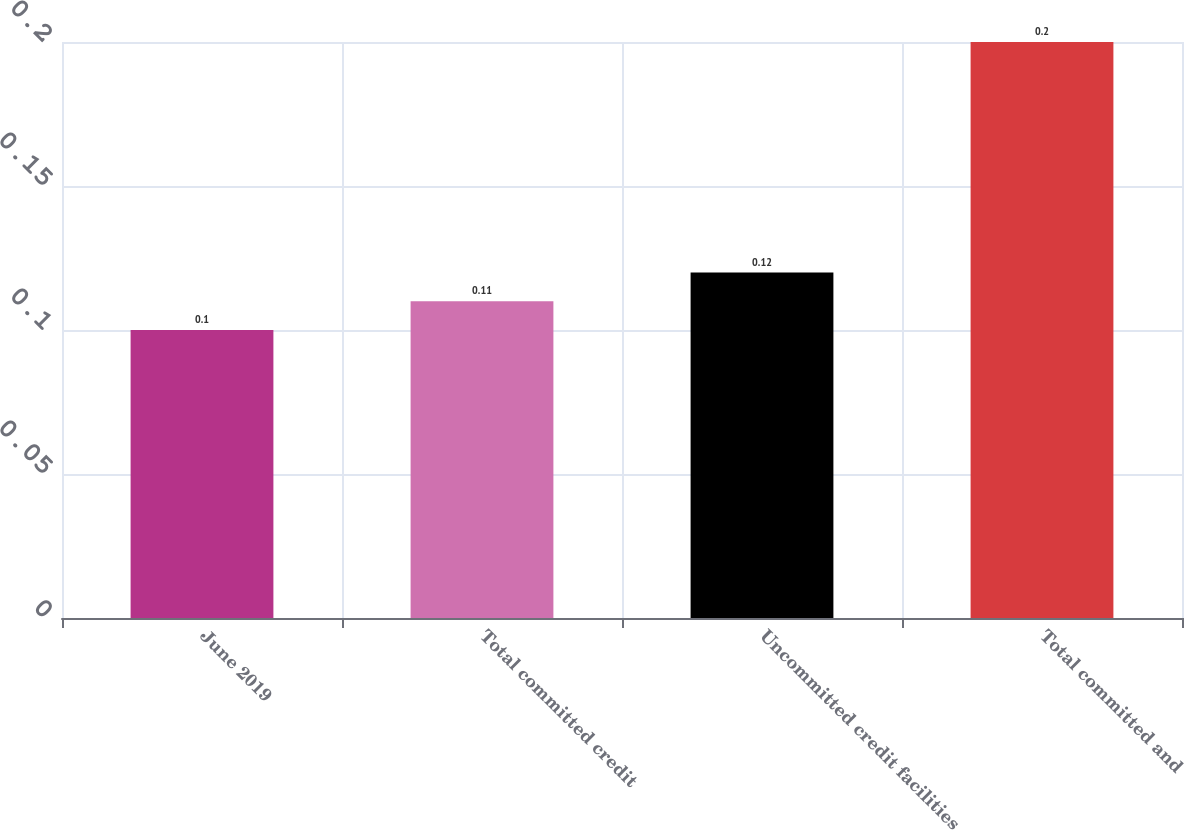Convert chart. <chart><loc_0><loc_0><loc_500><loc_500><bar_chart><fcel>June 2019<fcel>Total committed credit<fcel>Uncommitted credit facilities<fcel>Total committed and<nl><fcel>0.1<fcel>0.11<fcel>0.12<fcel>0.2<nl></chart> 